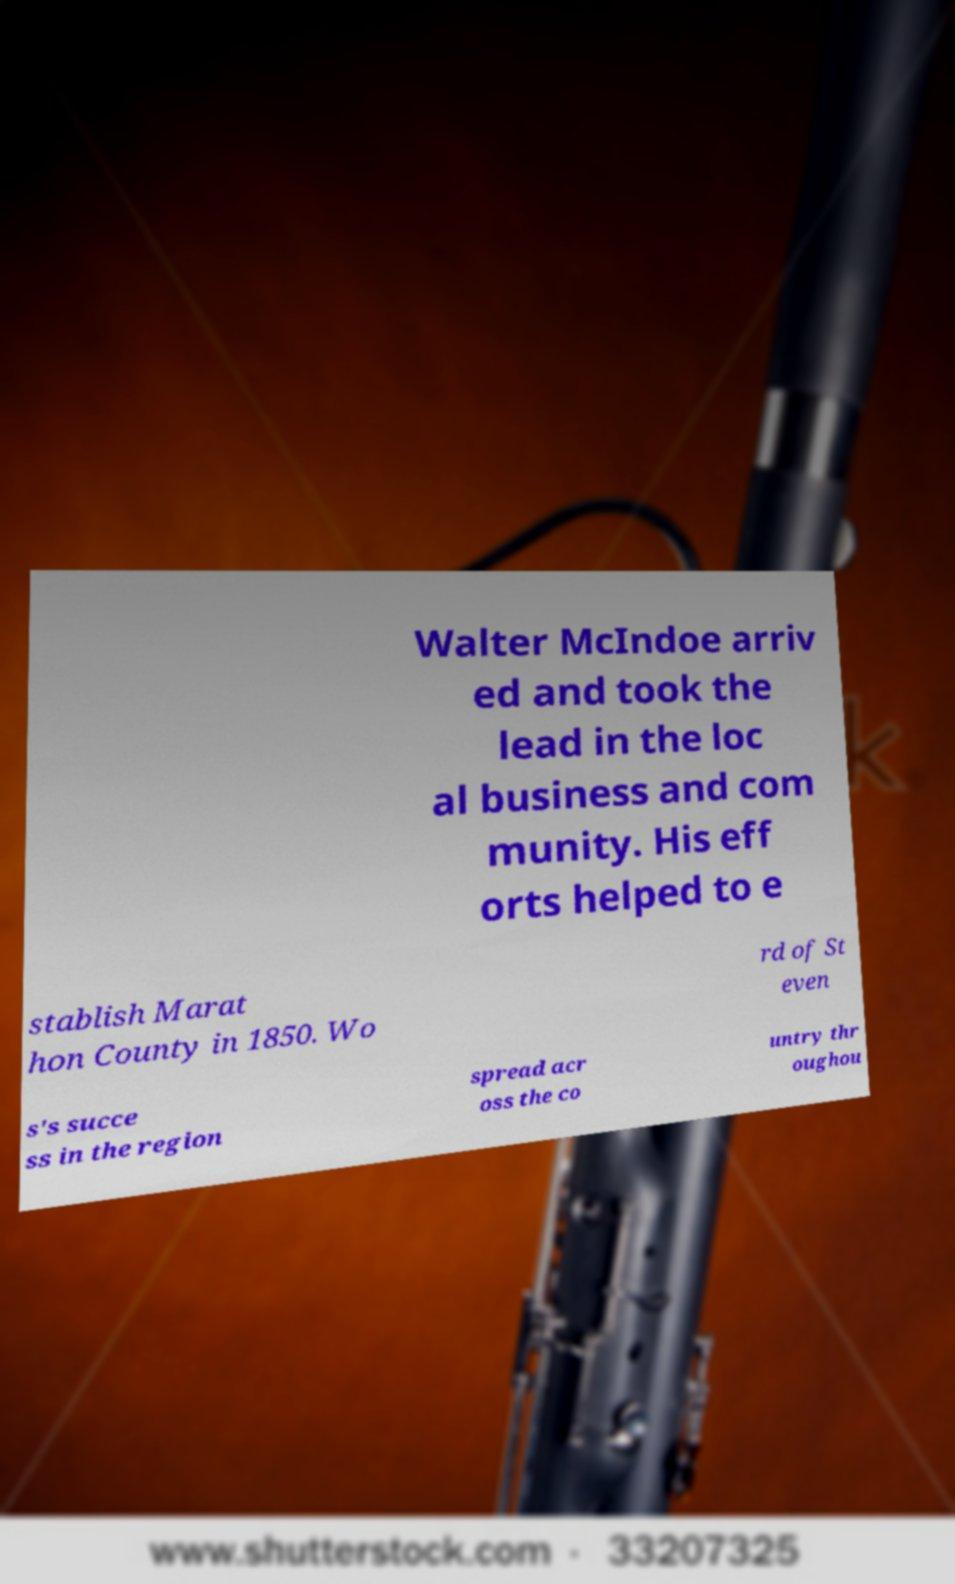Please read and relay the text visible in this image. What does it say? Walter McIndoe arriv ed and took the lead in the loc al business and com munity. His eff orts helped to e stablish Marat hon County in 1850. Wo rd of St even s's succe ss in the region spread acr oss the co untry thr oughou 